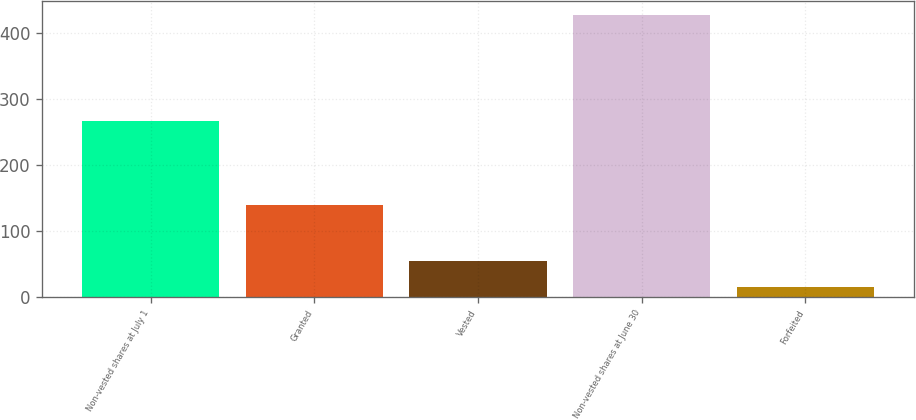Convert chart. <chart><loc_0><loc_0><loc_500><loc_500><bar_chart><fcel>Non-vested shares at July 1<fcel>Granted<fcel>Vested<fcel>Non-vested shares at June 30<fcel>Forfeited<nl><fcel>267<fcel>139<fcel>54.2<fcel>427.2<fcel>14<nl></chart> 